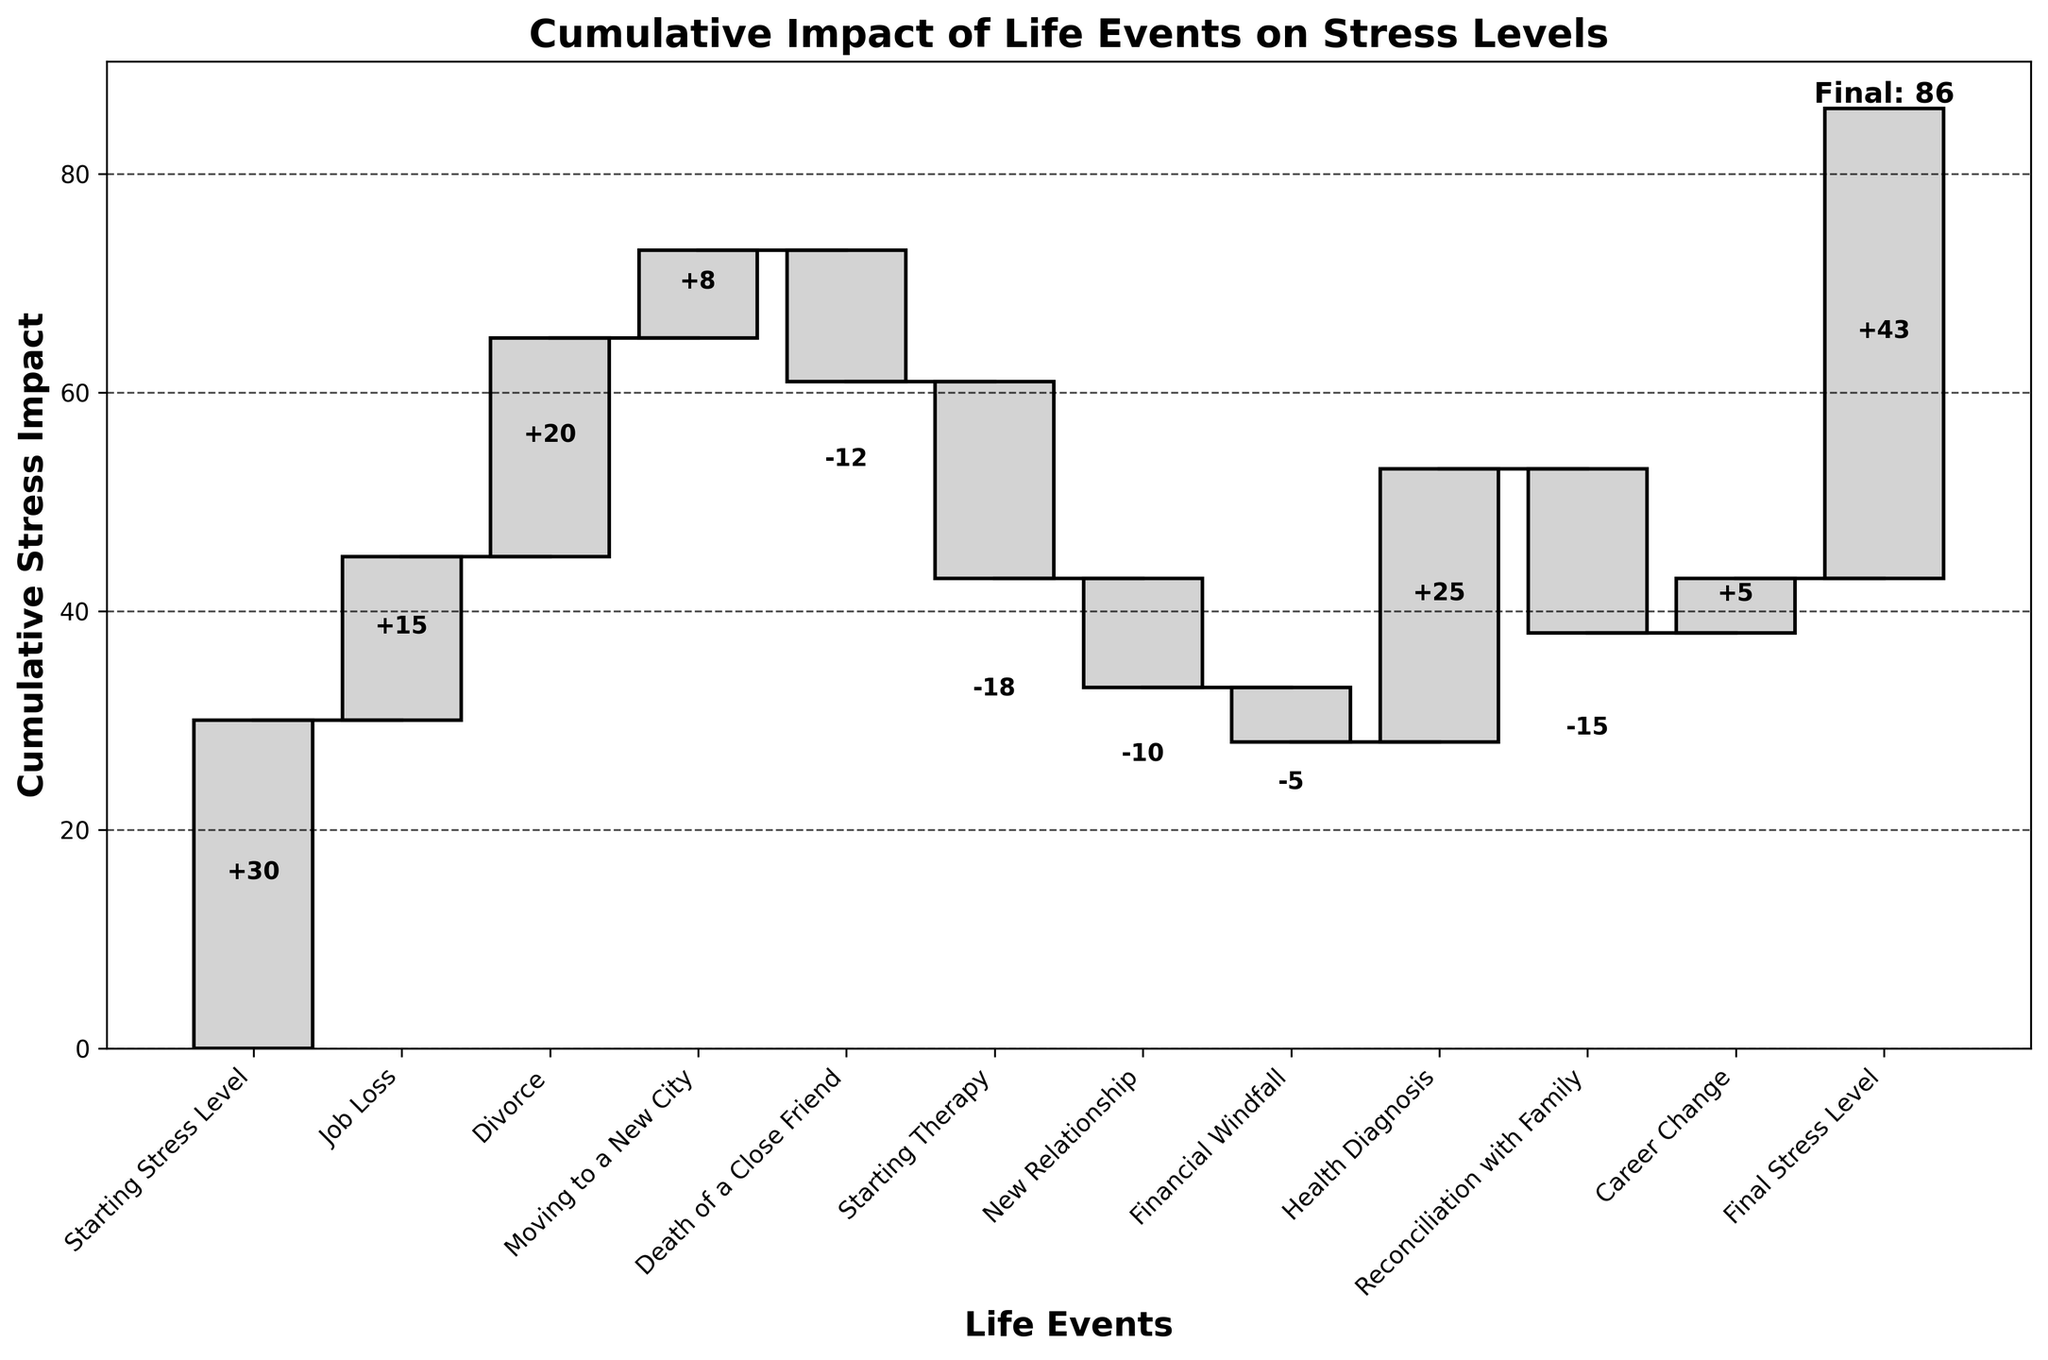What is the title of the plot? The title of the plot is displayed at the top. It helps in understanding the overall subject of the chart.
Answer: Cumulative Impact of Life Events on Stress Levels How many life events are represented in the plot? The x-axis of the chart lists each life event that contributes to stress levels. Counting them gives the number of events.
Answer: 11 What is the starting stress level? The starting stress level is the initial value before any life events impact the overall stress. It is usually the first data point.
Answer: 30 Which life event had the highest increase in stress? To determine which event had the highest increase, look for the bar with the highest positive value.
Answer: Health Diagnosis How did starting therapy impact stress levels? Look for the bar labeled "Starting Therapy" to check its impact. If the bar is negative, it indicates a reduction in stress levels.
Answer: -18 What was the cumulative stress level after the job loss? Find the "Job Loss" event bar and sum the impacts starting from the first to this event.
Answer: 45 Which event had a negative impact but did not fully eliminate previous stress levels? Identify events with negative impacts and check if the cumulative stress level remained positive after the event.
Answer: Reconciliation with Family What is the final stress level depicted in the plot? The final stress level is the cumulative impact after all events, usually the last data point in the chart.
Answer: 43 Compare the impact of the new relationship and the career change on stress levels. Which event had a bigger impact? Examine the bars for "New Relationship" and "Career Change" and compare their values.
Answer: Career Change By how much did the financial windfall reduce stress? Look for the bar labeled "Financial Windfall" and note its value to see the reduction.
Answer: -5 